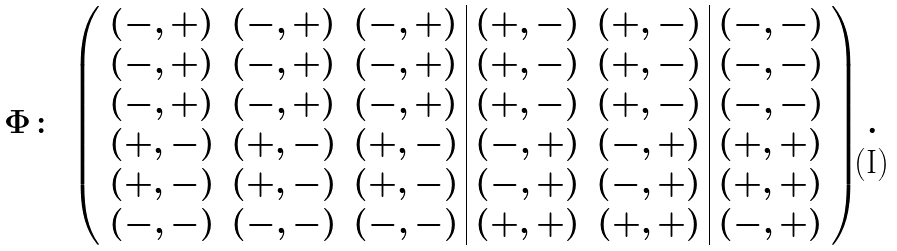<formula> <loc_0><loc_0><loc_500><loc_500>\Phi \colon \, \left ( \begin{array} { c c c | c c | c } ( - , + ) & ( - , + ) & ( - , + ) & ( + , - ) & ( + , - ) & ( - , - ) \\ ( - , + ) & ( - , + ) & ( - , + ) & ( + , - ) & ( + , - ) & ( - , - ) \\ ( - , + ) & ( - , + ) & ( - , + ) & ( + , - ) & ( + , - ) & ( - , - ) \\ ( + , - ) & ( + , - ) & ( + , - ) & ( - , + ) & ( - , + ) & ( + , + ) \\ ( + , - ) & ( + , - ) & ( + , - ) & ( - , + ) & ( - , + ) & ( + , + ) \\ ( - , - ) & ( - , - ) & ( - , - ) & ( + , + ) & ( + , + ) & ( - , + ) \end{array} \right ) .</formula> 